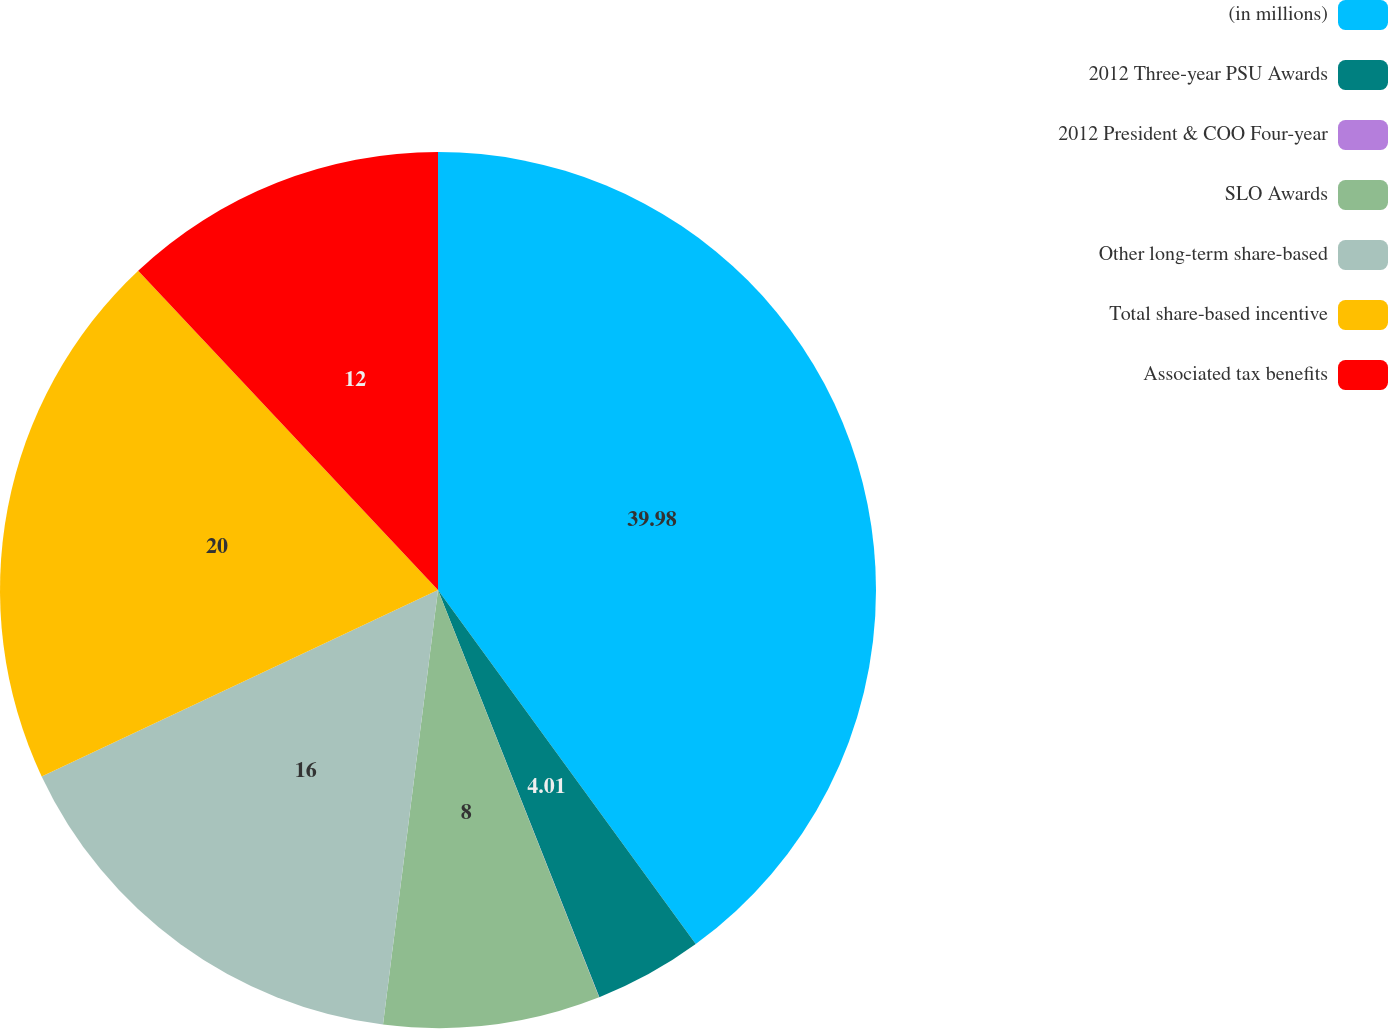Convert chart. <chart><loc_0><loc_0><loc_500><loc_500><pie_chart><fcel>(in millions)<fcel>2012 Three-year PSU Awards<fcel>2012 President & COO Four-year<fcel>SLO Awards<fcel>Other long-term share-based<fcel>Total share-based incentive<fcel>Associated tax benefits<nl><fcel>39.99%<fcel>4.01%<fcel>0.01%<fcel>8.0%<fcel>16.0%<fcel>20.0%<fcel>12.0%<nl></chart> 